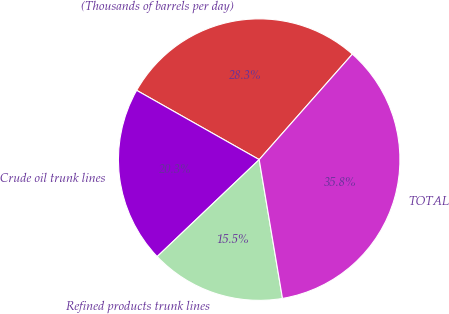Convert chart to OTSL. <chart><loc_0><loc_0><loc_500><loc_500><pie_chart><fcel>(Thousands of barrels per day)<fcel>Crude oil trunk lines<fcel>Refined products trunk lines<fcel>TOTAL<nl><fcel>28.33%<fcel>20.29%<fcel>15.55%<fcel>35.84%<nl></chart> 